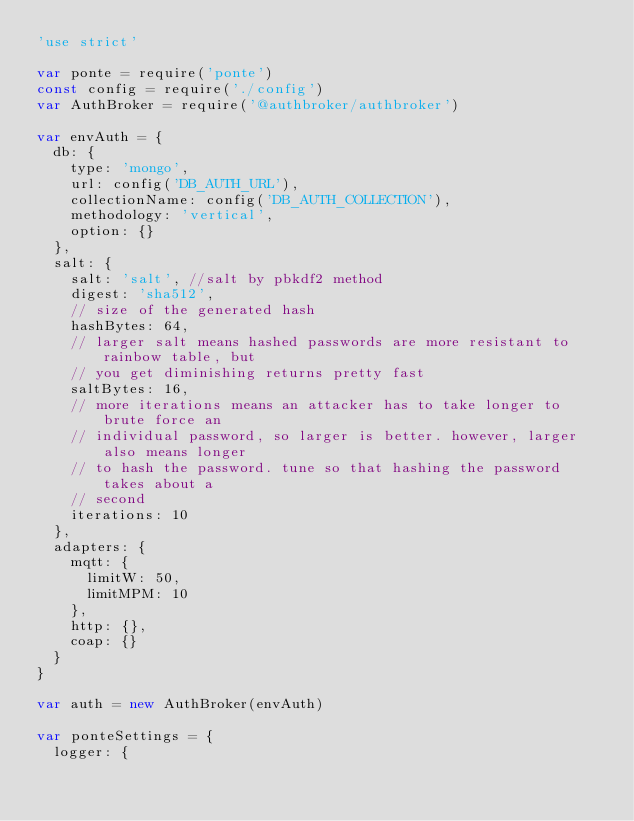<code> <loc_0><loc_0><loc_500><loc_500><_JavaScript_>'use strict'

var ponte = require('ponte')
const config = require('./config')
var AuthBroker = require('@authbroker/authbroker')

var envAuth = {
  db: {
    type: 'mongo',
    url: config('DB_AUTH_URL'),
    collectionName: config('DB_AUTH_COLLECTION'),
    methodology: 'vertical',
    option: {}
  },
  salt: {
    salt: 'salt', //salt by pbkdf2 method
    digest: 'sha512',
    // size of the generated hash
    hashBytes: 64,
    // larger salt means hashed passwords are more resistant to rainbow table, but
    // you get diminishing returns pretty fast
    saltBytes: 16,
    // more iterations means an attacker has to take longer to brute force an
    // individual password, so larger is better. however, larger also means longer
    // to hash the password. tune so that hashing the password takes about a
    // second
    iterations: 10
  },
  adapters: {
    mqtt: {
      limitW: 50,
      limitMPM: 10
    },
    http: {},
    coap: {}
  }
}

var auth = new AuthBroker(envAuth)

var ponteSettings = {
  logger: {</code> 